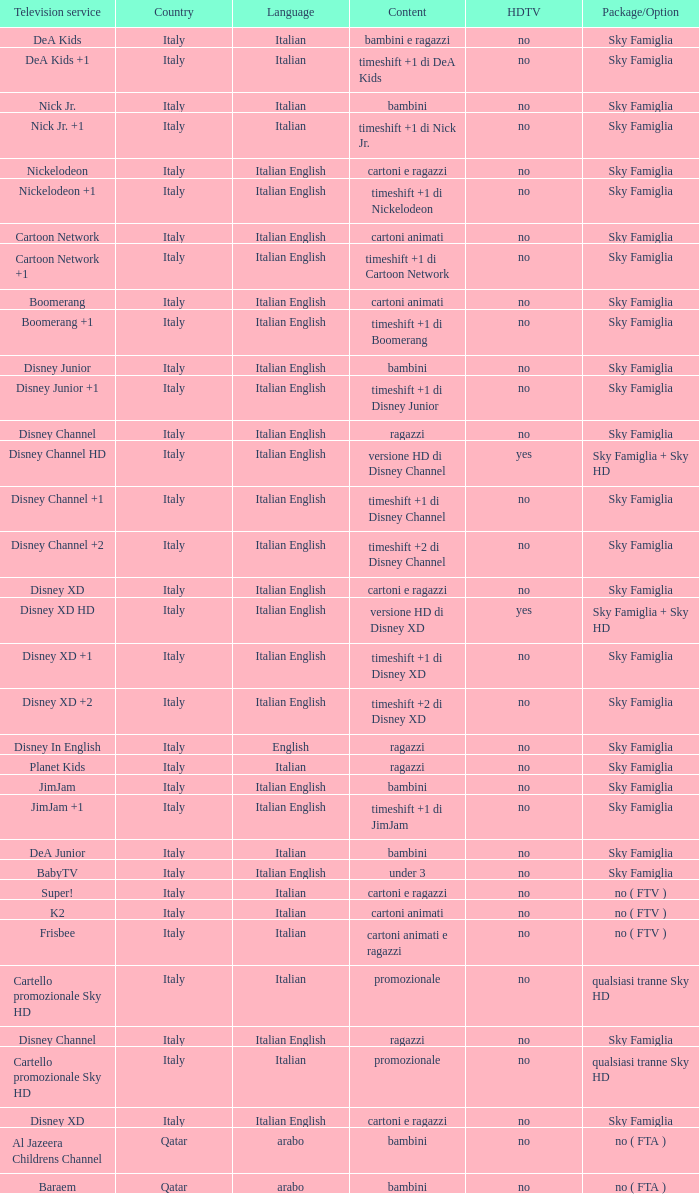What is the HDTV when the content shows a timeshift +1 di disney junior? No. 